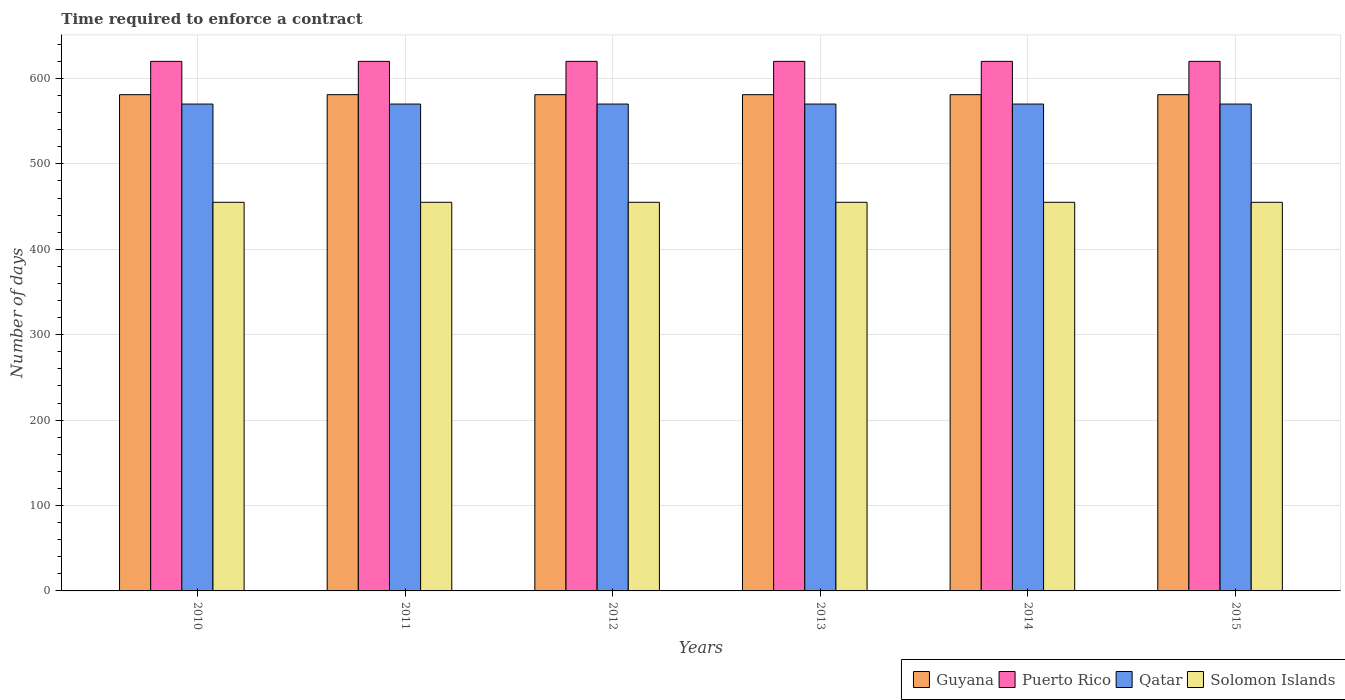How many different coloured bars are there?
Make the answer very short. 4. What is the label of the 1st group of bars from the left?
Provide a succinct answer. 2010. In how many cases, is the number of bars for a given year not equal to the number of legend labels?
Give a very brief answer. 0. What is the number of days required to enforce a contract in Qatar in 2013?
Provide a short and direct response. 570. Across all years, what is the maximum number of days required to enforce a contract in Solomon Islands?
Provide a succinct answer. 455. Across all years, what is the minimum number of days required to enforce a contract in Qatar?
Your answer should be compact. 570. What is the total number of days required to enforce a contract in Solomon Islands in the graph?
Give a very brief answer. 2730. What is the difference between the number of days required to enforce a contract in Qatar in 2015 and the number of days required to enforce a contract in Puerto Rico in 2014?
Provide a short and direct response. -50. What is the average number of days required to enforce a contract in Puerto Rico per year?
Your response must be concise. 620. In the year 2014, what is the difference between the number of days required to enforce a contract in Solomon Islands and number of days required to enforce a contract in Guyana?
Provide a succinct answer. -126. In how many years, is the number of days required to enforce a contract in Guyana greater than 520 days?
Give a very brief answer. 6. What is the ratio of the number of days required to enforce a contract in Solomon Islands in 2010 to that in 2014?
Give a very brief answer. 1. What is the difference between the highest and the second highest number of days required to enforce a contract in Guyana?
Provide a short and direct response. 0. Is it the case that in every year, the sum of the number of days required to enforce a contract in Solomon Islands and number of days required to enforce a contract in Guyana is greater than the sum of number of days required to enforce a contract in Puerto Rico and number of days required to enforce a contract in Qatar?
Your response must be concise. No. What does the 2nd bar from the left in 2010 represents?
Provide a short and direct response. Puerto Rico. What does the 4th bar from the right in 2011 represents?
Ensure brevity in your answer.  Guyana. Is it the case that in every year, the sum of the number of days required to enforce a contract in Solomon Islands and number of days required to enforce a contract in Guyana is greater than the number of days required to enforce a contract in Qatar?
Ensure brevity in your answer.  Yes. Are all the bars in the graph horizontal?
Ensure brevity in your answer.  No. How are the legend labels stacked?
Offer a very short reply. Horizontal. What is the title of the graph?
Keep it short and to the point. Time required to enforce a contract. What is the label or title of the X-axis?
Offer a very short reply. Years. What is the label or title of the Y-axis?
Keep it short and to the point. Number of days. What is the Number of days in Guyana in 2010?
Provide a succinct answer. 581. What is the Number of days of Puerto Rico in 2010?
Keep it short and to the point. 620. What is the Number of days in Qatar in 2010?
Provide a succinct answer. 570. What is the Number of days of Solomon Islands in 2010?
Your answer should be compact. 455. What is the Number of days in Guyana in 2011?
Offer a terse response. 581. What is the Number of days of Puerto Rico in 2011?
Keep it short and to the point. 620. What is the Number of days of Qatar in 2011?
Make the answer very short. 570. What is the Number of days of Solomon Islands in 2011?
Offer a terse response. 455. What is the Number of days of Guyana in 2012?
Provide a succinct answer. 581. What is the Number of days in Puerto Rico in 2012?
Ensure brevity in your answer.  620. What is the Number of days of Qatar in 2012?
Offer a very short reply. 570. What is the Number of days in Solomon Islands in 2012?
Your answer should be very brief. 455. What is the Number of days of Guyana in 2013?
Your response must be concise. 581. What is the Number of days in Puerto Rico in 2013?
Ensure brevity in your answer.  620. What is the Number of days of Qatar in 2013?
Ensure brevity in your answer.  570. What is the Number of days of Solomon Islands in 2013?
Offer a very short reply. 455. What is the Number of days in Guyana in 2014?
Provide a succinct answer. 581. What is the Number of days of Puerto Rico in 2014?
Provide a short and direct response. 620. What is the Number of days of Qatar in 2014?
Give a very brief answer. 570. What is the Number of days in Solomon Islands in 2014?
Ensure brevity in your answer.  455. What is the Number of days in Guyana in 2015?
Your response must be concise. 581. What is the Number of days of Puerto Rico in 2015?
Provide a short and direct response. 620. What is the Number of days of Qatar in 2015?
Provide a succinct answer. 570. What is the Number of days in Solomon Islands in 2015?
Your response must be concise. 455. Across all years, what is the maximum Number of days of Guyana?
Offer a terse response. 581. Across all years, what is the maximum Number of days of Puerto Rico?
Your answer should be compact. 620. Across all years, what is the maximum Number of days of Qatar?
Your answer should be very brief. 570. Across all years, what is the maximum Number of days of Solomon Islands?
Offer a terse response. 455. Across all years, what is the minimum Number of days of Guyana?
Give a very brief answer. 581. Across all years, what is the minimum Number of days in Puerto Rico?
Your answer should be compact. 620. Across all years, what is the minimum Number of days of Qatar?
Make the answer very short. 570. Across all years, what is the minimum Number of days of Solomon Islands?
Keep it short and to the point. 455. What is the total Number of days in Guyana in the graph?
Your response must be concise. 3486. What is the total Number of days of Puerto Rico in the graph?
Keep it short and to the point. 3720. What is the total Number of days of Qatar in the graph?
Offer a very short reply. 3420. What is the total Number of days in Solomon Islands in the graph?
Offer a very short reply. 2730. What is the difference between the Number of days in Solomon Islands in 2010 and that in 2011?
Offer a very short reply. 0. What is the difference between the Number of days of Solomon Islands in 2010 and that in 2012?
Keep it short and to the point. 0. What is the difference between the Number of days in Puerto Rico in 2010 and that in 2013?
Offer a terse response. 0. What is the difference between the Number of days in Solomon Islands in 2010 and that in 2014?
Keep it short and to the point. 0. What is the difference between the Number of days of Puerto Rico in 2010 and that in 2015?
Ensure brevity in your answer.  0. What is the difference between the Number of days in Qatar in 2010 and that in 2015?
Offer a very short reply. 0. What is the difference between the Number of days in Guyana in 2011 and that in 2012?
Keep it short and to the point. 0. What is the difference between the Number of days of Qatar in 2011 and that in 2012?
Ensure brevity in your answer.  0. What is the difference between the Number of days in Solomon Islands in 2011 and that in 2012?
Your answer should be compact. 0. What is the difference between the Number of days in Guyana in 2011 and that in 2013?
Ensure brevity in your answer.  0. What is the difference between the Number of days in Puerto Rico in 2011 and that in 2013?
Your answer should be very brief. 0. What is the difference between the Number of days of Guyana in 2011 and that in 2014?
Provide a short and direct response. 0. What is the difference between the Number of days of Qatar in 2011 and that in 2014?
Offer a very short reply. 0. What is the difference between the Number of days in Guyana in 2011 and that in 2015?
Ensure brevity in your answer.  0. What is the difference between the Number of days of Puerto Rico in 2011 and that in 2015?
Ensure brevity in your answer.  0. What is the difference between the Number of days in Qatar in 2011 and that in 2015?
Your answer should be compact. 0. What is the difference between the Number of days in Guyana in 2012 and that in 2013?
Your answer should be compact. 0. What is the difference between the Number of days of Solomon Islands in 2012 and that in 2013?
Make the answer very short. 0. What is the difference between the Number of days of Qatar in 2012 and that in 2014?
Give a very brief answer. 0. What is the difference between the Number of days of Guyana in 2012 and that in 2015?
Provide a succinct answer. 0. What is the difference between the Number of days of Puerto Rico in 2012 and that in 2015?
Provide a short and direct response. 0. What is the difference between the Number of days of Qatar in 2012 and that in 2015?
Give a very brief answer. 0. What is the difference between the Number of days in Solomon Islands in 2012 and that in 2015?
Offer a terse response. 0. What is the difference between the Number of days of Guyana in 2013 and that in 2014?
Ensure brevity in your answer.  0. What is the difference between the Number of days of Solomon Islands in 2013 and that in 2014?
Your answer should be very brief. 0. What is the difference between the Number of days of Puerto Rico in 2013 and that in 2015?
Offer a terse response. 0. What is the difference between the Number of days in Qatar in 2013 and that in 2015?
Provide a short and direct response. 0. What is the difference between the Number of days of Qatar in 2014 and that in 2015?
Provide a succinct answer. 0. What is the difference between the Number of days of Solomon Islands in 2014 and that in 2015?
Keep it short and to the point. 0. What is the difference between the Number of days in Guyana in 2010 and the Number of days in Puerto Rico in 2011?
Make the answer very short. -39. What is the difference between the Number of days of Guyana in 2010 and the Number of days of Qatar in 2011?
Offer a very short reply. 11. What is the difference between the Number of days of Guyana in 2010 and the Number of days of Solomon Islands in 2011?
Keep it short and to the point. 126. What is the difference between the Number of days of Puerto Rico in 2010 and the Number of days of Solomon Islands in 2011?
Provide a succinct answer. 165. What is the difference between the Number of days of Qatar in 2010 and the Number of days of Solomon Islands in 2011?
Provide a short and direct response. 115. What is the difference between the Number of days of Guyana in 2010 and the Number of days of Puerto Rico in 2012?
Make the answer very short. -39. What is the difference between the Number of days in Guyana in 2010 and the Number of days in Qatar in 2012?
Make the answer very short. 11. What is the difference between the Number of days in Guyana in 2010 and the Number of days in Solomon Islands in 2012?
Provide a succinct answer. 126. What is the difference between the Number of days of Puerto Rico in 2010 and the Number of days of Solomon Islands in 2012?
Ensure brevity in your answer.  165. What is the difference between the Number of days of Qatar in 2010 and the Number of days of Solomon Islands in 2012?
Your response must be concise. 115. What is the difference between the Number of days in Guyana in 2010 and the Number of days in Puerto Rico in 2013?
Provide a short and direct response. -39. What is the difference between the Number of days in Guyana in 2010 and the Number of days in Qatar in 2013?
Make the answer very short. 11. What is the difference between the Number of days of Guyana in 2010 and the Number of days of Solomon Islands in 2013?
Your answer should be very brief. 126. What is the difference between the Number of days in Puerto Rico in 2010 and the Number of days in Qatar in 2013?
Offer a terse response. 50. What is the difference between the Number of days in Puerto Rico in 2010 and the Number of days in Solomon Islands in 2013?
Provide a succinct answer. 165. What is the difference between the Number of days in Qatar in 2010 and the Number of days in Solomon Islands in 2013?
Offer a very short reply. 115. What is the difference between the Number of days of Guyana in 2010 and the Number of days of Puerto Rico in 2014?
Ensure brevity in your answer.  -39. What is the difference between the Number of days of Guyana in 2010 and the Number of days of Solomon Islands in 2014?
Provide a succinct answer. 126. What is the difference between the Number of days of Puerto Rico in 2010 and the Number of days of Qatar in 2014?
Keep it short and to the point. 50. What is the difference between the Number of days of Puerto Rico in 2010 and the Number of days of Solomon Islands in 2014?
Keep it short and to the point. 165. What is the difference between the Number of days in Qatar in 2010 and the Number of days in Solomon Islands in 2014?
Your response must be concise. 115. What is the difference between the Number of days of Guyana in 2010 and the Number of days of Puerto Rico in 2015?
Make the answer very short. -39. What is the difference between the Number of days of Guyana in 2010 and the Number of days of Qatar in 2015?
Give a very brief answer. 11. What is the difference between the Number of days of Guyana in 2010 and the Number of days of Solomon Islands in 2015?
Make the answer very short. 126. What is the difference between the Number of days in Puerto Rico in 2010 and the Number of days in Qatar in 2015?
Make the answer very short. 50. What is the difference between the Number of days in Puerto Rico in 2010 and the Number of days in Solomon Islands in 2015?
Make the answer very short. 165. What is the difference between the Number of days in Qatar in 2010 and the Number of days in Solomon Islands in 2015?
Provide a short and direct response. 115. What is the difference between the Number of days of Guyana in 2011 and the Number of days of Puerto Rico in 2012?
Your response must be concise. -39. What is the difference between the Number of days in Guyana in 2011 and the Number of days in Solomon Islands in 2012?
Your answer should be compact. 126. What is the difference between the Number of days in Puerto Rico in 2011 and the Number of days in Solomon Islands in 2012?
Your response must be concise. 165. What is the difference between the Number of days in Qatar in 2011 and the Number of days in Solomon Islands in 2012?
Your response must be concise. 115. What is the difference between the Number of days of Guyana in 2011 and the Number of days of Puerto Rico in 2013?
Offer a terse response. -39. What is the difference between the Number of days in Guyana in 2011 and the Number of days in Qatar in 2013?
Offer a very short reply. 11. What is the difference between the Number of days in Guyana in 2011 and the Number of days in Solomon Islands in 2013?
Your answer should be very brief. 126. What is the difference between the Number of days in Puerto Rico in 2011 and the Number of days in Qatar in 2013?
Ensure brevity in your answer.  50. What is the difference between the Number of days in Puerto Rico in 2011 and the Number of days in Solomon Islands in 2013?
Provide a succinct answer. 165. What is the difference between the Number of days of Qatar in 2011 and the Number of days of Solomon Islands in 2013?
Offer a terse response. 115. What is the difference between the Number of days of Guyana in 2011 and the Number of days of Puerto Rico in 2014?
Provide a short and direct response. -39. What is the difference between the Number of days in Guyana in 2011 and the Number of days in Qatar in 2014?
Ensure brevity in your answer.  11. What is the difference between the Number of days in Guyana in 2011 and the Number of days in Solomon Islands in 2014?
Provide a short and direct response. 126. What is the difference between the Number of days of Puerto Rico in 2011 and the Number of days of Qatar in 2014?
Your answer should be very brief. 50. What is the difference between the Number of days of Puerto Rico in 2011 and the Number of days of Solomon Islands in 2014?
Make the answer very short. 165. What is the difference between the Number of days in Qatar in 2011 and the Number of days in Solomon Islands in 2014?
Your response must be concise. 115. What is the difference between the Number of days in Guyana in 2011 and the Number of days in Puerto Rico in 2015?
Your answer should be compact. -39. What is the difference between the Number of days of Guyana in 2011 and the Number of days of Qatar in 2015?
Give a very brief answer. 11. What is the difference between the Number of days of Guyana in 2011 and the Number of days of Solomon Islands in 2015?
Ensure brevity in your answer.  126. What is the difference between the Number of days of Puerto Rico in 2011 and the Number of days of Qatar in 2015?
Your response must be concise. 50. What is the difference between the Number of days in Puerto Rico in 2011 and the Number of days in Solomon Islands in 2015?
Ensure brevity in your answer.  165. What is the difference between the Number of days in Qatar in 2011 and the Number of days in Solomon Islands in 2015?
Give a very brief answer. 115. What is the difference between the Number of days in Guyana in 2012 and the Number of days in Puerto Rico in 2013?
Give a very brief answer. -39. What is the difference between the Number of days of Guyana in 2012 and the Number of days of Solomon Islands in 2013?
Ensure brevity in your answer.  126. What is the difference between the Number of days in Puerto Rico in 2012 and the Number of days in Qatar in 2013?
Make the answer very short. 50. What is the difference between the Number of days in Puerto Rico in 2012 and the Number of days in Solomon Islands in 2013?
Make the answer very short. 165. What is the difference between the Number of days of Qatar in 2012 and the Number of days of Solomon Islands in 2013?
Provide a short and direct response. 115. What is the difference between the Number of days in Guyana in 2012 and the Number of days in Puerto Rico in 2014?
Provide a short and direct response. -39. What is the difference between the Number of days in Guyana in 2012 and the Number of days in Solomon Islands in 2014?
Offer a very short reply. 126. What is the difference between the Number of days in Puerto Rico in 2012 and the Number of days in Solomon Islands in 2014?
Your answer should be compact. 165. What is the difference between the Number of days in Qatar in 2012 and the Number of days in Solomon Islands in 2014?
Your response must be concise. 115. What is the difference between the Number of days of Guyana in 2012 and the Number of days of Puerto Rico in 2015?
Offer a very short reply. -39. What is the difference between the Number of days of Guyana in 2012 and the Number of days of Qatar in 2015?
Your response must be concise. 11. What is the difference between the Number of days of Guyana in 2012 and the Number of days of Solomon Islands in 2015?
Ensure brevity in your answer.  126. What is the difference between the Number of days of Puerto Rico in 2012 and the Number of days of Qatar in 2015?
Make the answer very short. 50. What is the difference between the Number of days in Puerto Rico in 2012 and the Number of days in Solomon Islands in 2015?
Provide a succinct answer. 165. What is the difference between the Number of days of Qatar in 2012 and the Number of days of Solomon Islands in 2015?
Make the answer very short. 115. What is the difference between the Number of days in Guyana in 2013 and the Number of days in Puerto Rico in 2014?
Your answer should be very brief. -39. What is the difference between the Number of days in Guyana in 2013 and the Number of days in Solomon Islands in 2014?
Provide a succinct answer. 126. What is the difference between the Number of days in Puerto Rico in 2013 and the Number of days in Solomon Islands in 2014?
Provide a short and direct response. 165. What is the difference between the Number of days of Qatar in 2013 and the Number of days of Solomon Islands in 2014?
Offer a very short reply. 115. What is the difference between the Number of days of Guyana in 2013 and the Number of days of Puerto Rico in 2015?
Provide a short and direct response. -39. What is the difference between the Number of days in Guyana in 2013 and the Number of days in Qatar in 2015?
Your answer should be compact. 11. What is the difference between the Number of days in Guyana in 2013 and the Number of days in Solomon Islands in 2015?
Keep it short and to the point. 126. What is the difference between the Number of days of Puerto Rico in 2013 and the Number of days of Solomon Islands in 2015?
Your answer should be very brief. 165. What is the difference between the Number of days of Qatar in 2013 and the Number of days of Solomon Islands in 2015?
Give a very brief answer. 115. What is the difference between the Number of days in Guyana in 2014 and the Number of days in Puerto Rico in 2015?
Offer a very short reply. -39. What is the difference between the Number of days of Guyana in 2014 and the Number of days of Solomon Islands in 2015?
Offer a terse response. 126. What is the difference between the Number of days in Puerto Rico in 2014 and the Number of days in Qatar in 2015?
Offer a very short reply. 50. What is the difference between the Number of days of Puerto Rico in 2014 and the Number of days of Solomon Islands in 2015?
Your response must be concise. 165. What is the difference between the Number of days of Qatar in 2014 and the Number of days of Solomon Islands in 2015?
Your answer should be compact. 115. What is the average Number of days in Guyana per year?
Offer a terse response. 581. What is the average Number of days in Puerto Rico per year?
Offer a very short reply. 620. What is the average Number of days of Qatar per year?
Make the answer very short. 570. What is the average Number of days of Solomon Islands per year?
Ensure brevity in your answer.  455. In the year 2010, what is the difference between the Number of days in Guyana and Number of days in Puerto Rico?
Provide a succinct answer. -39. In the year 2010, what is the difference between the Number of days of Guyana and Number of days of Solomon Islands?
Provide a succinct answer. 126. In the year 2010, what is the difference between the Number of days in Puerto Rico and Number of days in Solomon Islands?
Keep it short and to the point. 165. In the year 2010, what is the difference between the Number of days in Qatar and Number of days in Solomon Islands?
Offer a very short reply. 115. In the year 2011, what is the difference between the Number of days of Guyana and Number of days of Puerto Rico?
Provide a succinct answer. -39. In the year 2011, what is the difference between the Number of days of Guyana and Number of days of Solomon Islands?
Make the answer very short. 126. In the year 2011, what is the difference between the Number of days in Puerto Rico and Number of days in Qatar?
Make the answer very short. 50. In the year 2011, what is the difference between the Number of days of Puerto Rico and Number of days of Solomon Islands?
Give a very brief answer. 165. In the year 2011, what is the difference between the Number of days in Qatar and Number of days in Solomon Islands?
Provide a short and direct response. 115. In the year 2012, what is the difference between the Number of days in Guyana and Number of days in Puerto Rico?
Give a very brief answer. -39. In the year 2012, what is the difference between the Number of days of Guyana and Number of days of Qatar?
Provide a short and direct response. 11. In the year 2012, what is the difference between the Number of days of Guyana and Number of days of Solomon Islands?
Offer a terse response. 126. In the year 2012, what is the difference between the Number of days in Puerto Rico and Number of days in Solomon Islands?
Give a very brief answer. 165. In the year 2012, what is the difference between the Number of days in Qatar and Number of days in Solomon Islands?
Ensure brevity in your answer.  115. In the year 2013, what is the difference between the Number of days of Guyana and Number of days of Puerto Rico?
Give a very brief answer. -39. In the year 2013, what is the difference between the Number of days of Guyana and Number of days of Qatar?
Give a very brief answer. 11. In the year 2013, what is the difference between the Number of days in Guyana and Number of days in Solomon Islands?
Offer a terse response. 126. In the year 2013, what is the difference between the Number of days of Puerto Rico and Number of days of Solomon Islands?
Your answer should be compact. 165. In the year 2013, what is the difference between the Number of days of Qatar and Number of days of Solomon Islands?
Keep it short and to the point. 115. In the year 2014, what is the difference between the Number of days in Guyana and Number of days in Puerto Rico?
Your answer should be compact. -39. In the year 2014, what is the difference between the Number of days of Guyana and Number of days of Qatar?
Give a very brief answer. 11. In the year 2014, what is the difference between the Number of days in Guyana and Number of days in Solomon Islands?
Offer a very short reply. 126. In the year 2014, what is the difference between the Number of days in Puerto Rico and Number of days in Solomon Islands?
Your response must be concise. 165. In the year 2014, what is the difference between the Number of days in Qatar and Number of days in Solomon Islands?
Your answer should be very brief. 115. In the year 2015, what is the difference between the Number of days in Guyana and Number of days in Puerto Rico?
Your response must be concise. -39. In the year 2015, what is the difference between the Number of days of Guyana and Number of days of Qatar?
Your answer should be very brief. 11. In the year 2015, what is the difference between the Number of days of Guyana and Number of days of Solomon Islands?
Your answer should be compact. 126. In the year 2015, what is the difference between the Number of days in Puerto Rico and Number of days in Qatar?
Offer a very short reply. 50. In the year 2015, what is the difference between the Number of days in Puerto Rico and Number of days in Solomon Islands?
Your response must be concise. 165. In the year 2015, what is the difference between the Number of days of Qatar and Number of days of Solomon Islands?
Your answer should be very brief. 115. What is the ratio of the Number of days in Guyana in 2010 to that in 2011?
Your response must be concise. 1. What is the ratio of the Number of days of Solomon Islands in 2010 to that in 2013?
Your response must be concise. 1. What is the ratio of the Number of days of Qatar in 2010 to that in 2014?
Your response must be concise. 1. What is the ratio of the Number of days of Guyana in 2010 to that in 2015?
Keep it short and to the point. 1. What is the ratio of the Number of days in Puerto Rico in 2010 to that in 2015?
Make the answer very short. 1. What is the ratio of the Number of days in Qatar in 2010 to that in 2015?
Provide a succinct answer. 1. What is the ratio of the Number of days in Solomon Islands in 2011 to that in 2012?
Offer a terse response. 1. What is the ratio of the Number of days of Qatar in 2011 to that in 2013?
Keep it short and to the point. 1. What is the ratio of the Number of days of Solomon Islands in 2011 to that in 2013?
Give a very brief answer. 1. What is the ratio of the Number of days in Qatar in 2011 to that in 2014?
Your answer should be compact. 1. What is the ratio of the Number of days in Guyana in 2011 to that in 2015?
Your answer should be compact. 1. What is the ratio of the Number of days in Puerto Rico in 2011 to that in 2015?
Your response must be concise. 1. What is the ratio of the Number of days of Qatar in 2011 to that in 2015?
Ensure brevity in your answer.  1. What is the ratio of the Number of days of Solomon Islands in 2011 to that in 2015?
Your response must be concise. 1. What is the ratio of the Number of days in Puerto Rico in 2012 to that in 2013?
Your response must be concise. 1. What is the ratio of the Number of days of Qatar in 2012 to that in 2013?
Ensure brevity in your answer.  1. What is the ratio of the Number of days in Qatar in 2012 to that in 2014?
Give a very brief answer. 1. What is the ratio of the Number of days of Puerto Rico in 2012 to that in 2015?
Offer a very short reply. 1. What is the ratio of the Number of days of Qatar in 2012 to that in 2015?
Make the answer very short. 1. What is the ratio of the Number of days in Guyana in 2013 to that in 2014?
Offer a very short reply. 1. What is the ratio of the Number of days of Qatar in 2013 to that in 2014?
Offer a terse response. 1. What is the ratio of the Number of days of Solomon Islands in 2013 to that in 2014?
Offer a terse response. 1. What is the ratio of the Number of days of Guyana in 2013 to that in 2015?
Provide a short and direct response. 1. What is the ratio of the Number of days in Puerto Rico in 2013 to that in 2015?
Keep it short and to the point. 1. What is the ratio of the Number of days in Qatar in 2013 to that in 2015?
Offer a very short reply. 1. What is the ratio of the Number of days in Guyana in 2014 to that in 2015?
Ensure brevity in your answer.  1. What is the ratio of the Number of days of Puerto Rico in 2014 to that in 2015?
Your answer should be compact. 1. What is the ratio of the Number of days in Solomon Islands in 2014 to that in 2015?
Provide a succinct answer. 1. What is the difference between the highest and the second highest Number of days of Guyana?
Offer a very short reply. 0. What is the difference between the highest and the second highest Number of days of Puerto Rico?
Your response must be concise. 0. What is the difference between the highest and the second highest Number of days of Solomon Islands?
Offer a terse response. 0. What is the difference between the highest and the lowest Number of days in Guyana?
Offer a terse response. 0. What is the difference between the highest and the lowest Number of days of Puerto Rico?
Give a very brief answer. 0. What is the difference between the highest and the lowest Number of days of Qatar?
Your answer should be very brief. 0. 